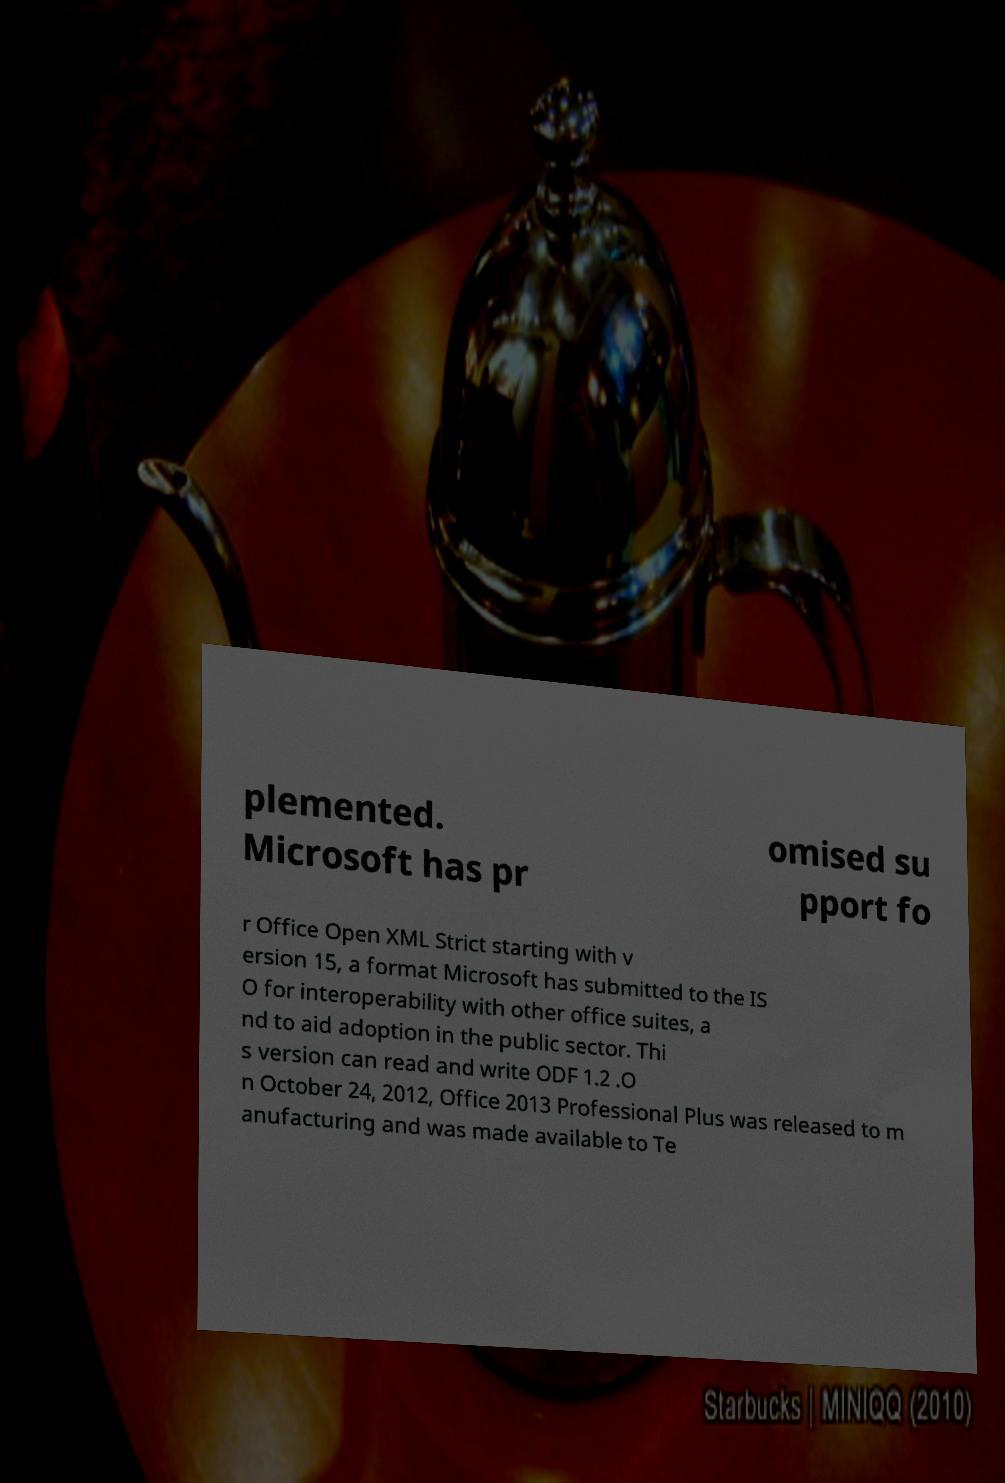Please identify and transcribe the text found in this image. plemented. Microsoft has pr omised su pport fo r Office Open XML Strict starting with v ersion 15, a format Microsoft has submitted to the IS O for interoperability with other office suites, a nd to aid adoption in the public sector. Thi s version can read and write ODF 1.2 .O n October 24, 2012, Office 2013 Professional Plus was released to m anufacturing and was made available to Te 